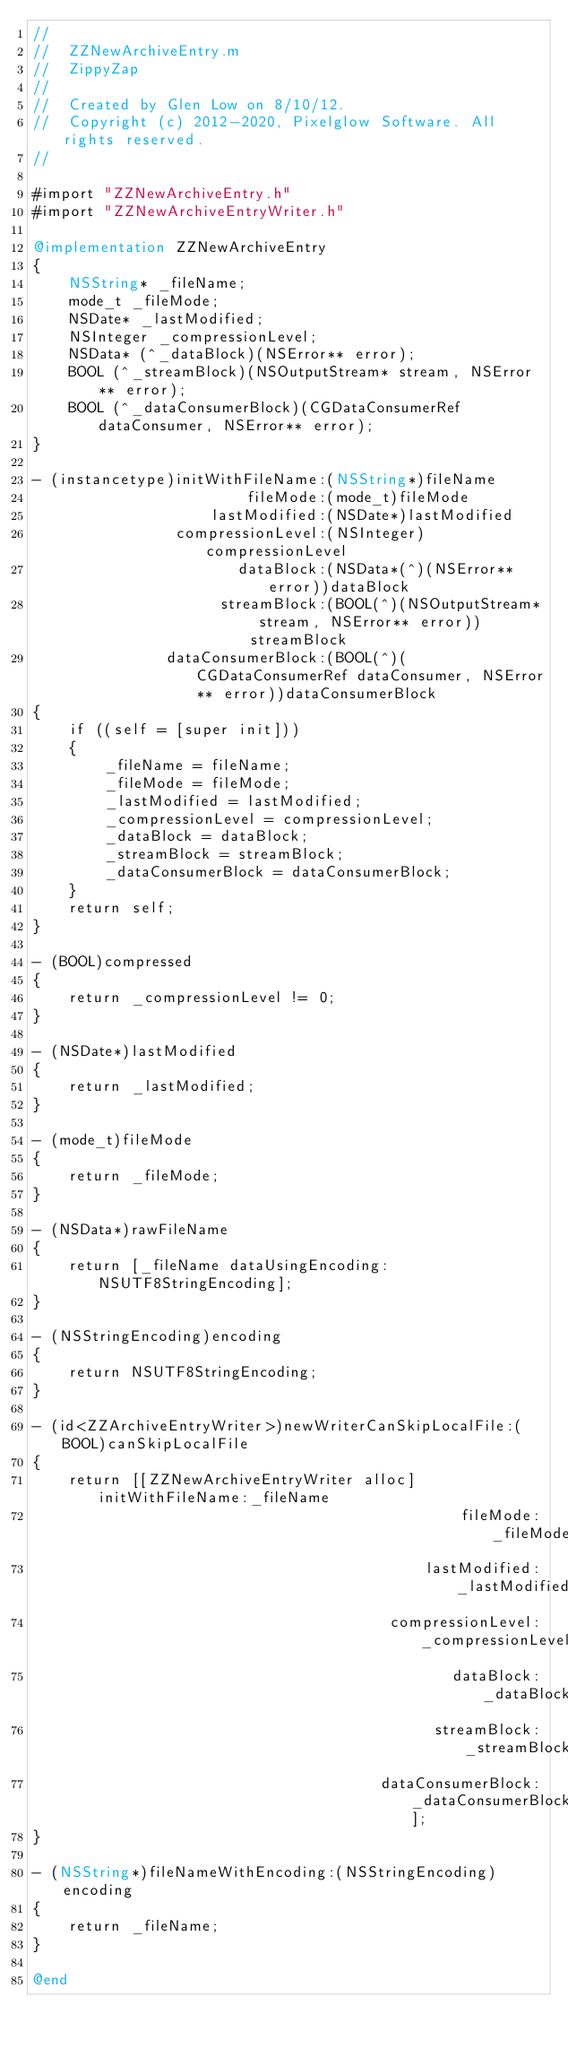Convert code to text. <code><loc_0><loc_0><loc_500><loc_500><_ObjectiveC_>//
//  ZZNewArchiveEntry.m
//  ZippyZap
//
//  Created by Glen Low on 8/10/12.
//  Copyright (c) 2012-2020, Pixelglow Software. All rights reserved.
//

#import "ZZNewArchiveEntry.h"
#import "ZZNewArchiveEntryWriter.h"

@implementation ZZNewArchiveEntry
{
	NSString* _fileName;
	mode_t _fileMode;
	NSDate* _lastModified;
	NSInteger _compressionLevel;
	NSData* (^_dataBlock)(NSError** error);
	BOOL (^_streamBlock)(NSOutputStream* stream, NSError** error);
	BOOL (^_dataConsumerBlock)(CGDataConsumerRef dataConsumer, NSError** error);
}

- (instancetype)initWithFileName:(NSString*)fileName
						fileMode:(mode_t)fileMode
					lastModified:(NSDate*)lastModified
				compressionLevel:(NSInteger)compressionLevel
					   dataBlock:(NSData*(^)(NSError** error))dataBlock
					 streamBlock:(BOOL(^)(NSOutputStream* stream, NSError** error))streamBlock
			   dataConsumerBlock:(BOOL(^)(CGDataConsumerRef dataConsumer, NSError** error))dataConsumerBlock
{
	if ((self = [super init]))
	{
		_fileName = fileName;
		_fileMode = fileMode;
		_lastModified = lastModified;
		_compressionLevel = compressionLevel;
		_dataBlock = dataBlock;
		_streamBlock = streamBlock;
		_dataConsumerBlock = dataConsumerBlock;
	}
	return self;
}

- (BOOL)compressed
{
	return _compressionLevel != 0;
}

- (NSDate*)lastModified
{
	return _lastModified;
}

- (mode_t)fileMode
{
	return _fileMode;
}

- (NSData*)rawFileName
{
	return [_fileName dataUsingEncoding:NSUTF8StringEncoding];
}

- (NSStringEncoding)encoding
{
	return NSUTF8StringEncoding;
}

- (id<ZZArchiveEntryWriter>)newWriterCanSkipLocalFile:(BOOL)canSkipLocalFile
{
	return [[ZZNewArchiveEntryWriter alloc] initWithFileName:_fileName
												fileMode:_fileMode
											lastModified:_lastModified
										compressionLevel:_compressionLevel
											   dataBlock:_dataBlock
											 streamBlock:_streamBlock
									   dataConsumerBlock:_dataConsumerBlock];
}

- (NSString*)fileNameWithEncoding:(NSStringEncoding)encoding
{
	return _fileName;
}

@end

</code> 